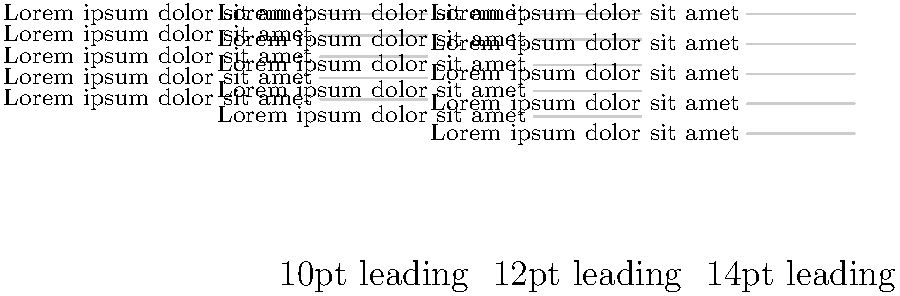Based on the visual representation of text blocks with different leading values, which leading value appears to provide the most optimal balance between readability and efficient use of space for body text in a typical academic publication? To determine the optimal leading value, we need to consider several factors:

1. Readability: Adequate spacing between lines improves readability by preventing text from appearing cramped or difficult to follow.

2. Efficient use of space: While generous leading can enhance readability, excessive spacing wastes valuable page real estate.

3. Visual harmony: The ideal leading should create a balanced and aesthetically pleasing text block.

4. Standard practices: In typography, a common rule of thumb is to set leading at 120-150% of the font size.

Analyzing the given examples:

a) 10pt leading: This appears cramped, with lines very close together. It may be difficult to read, especially for longer texts.

b) 12pt leading: This provides a more balanced appearance. There's enough space between lines to distinguish them easily, but not so much that it feels wasteful.

c) 14pt leading: While this is the most spacious, it may be considered excessive for body text in academic publications where space efficiency is often a concern.

Assuming a standard body text size of 10-11pt, the 12pt leading example aligns well with the 120-150% rule (120-132% of font size). It offers a good balance between readability and efficient use of space, making it the most suitable choice for academic publications.
Answer: 12pt leading 